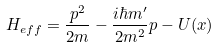<formula> <loc_0><loc_0><loc_500><loc_500>H _ { e f f } = \frac { p ^ { 2 } } { 2 m } - \frac { i \hbar { m } ^ { \prime } } { 2 m ^ { 2 } } p - U ( x )</formula> 